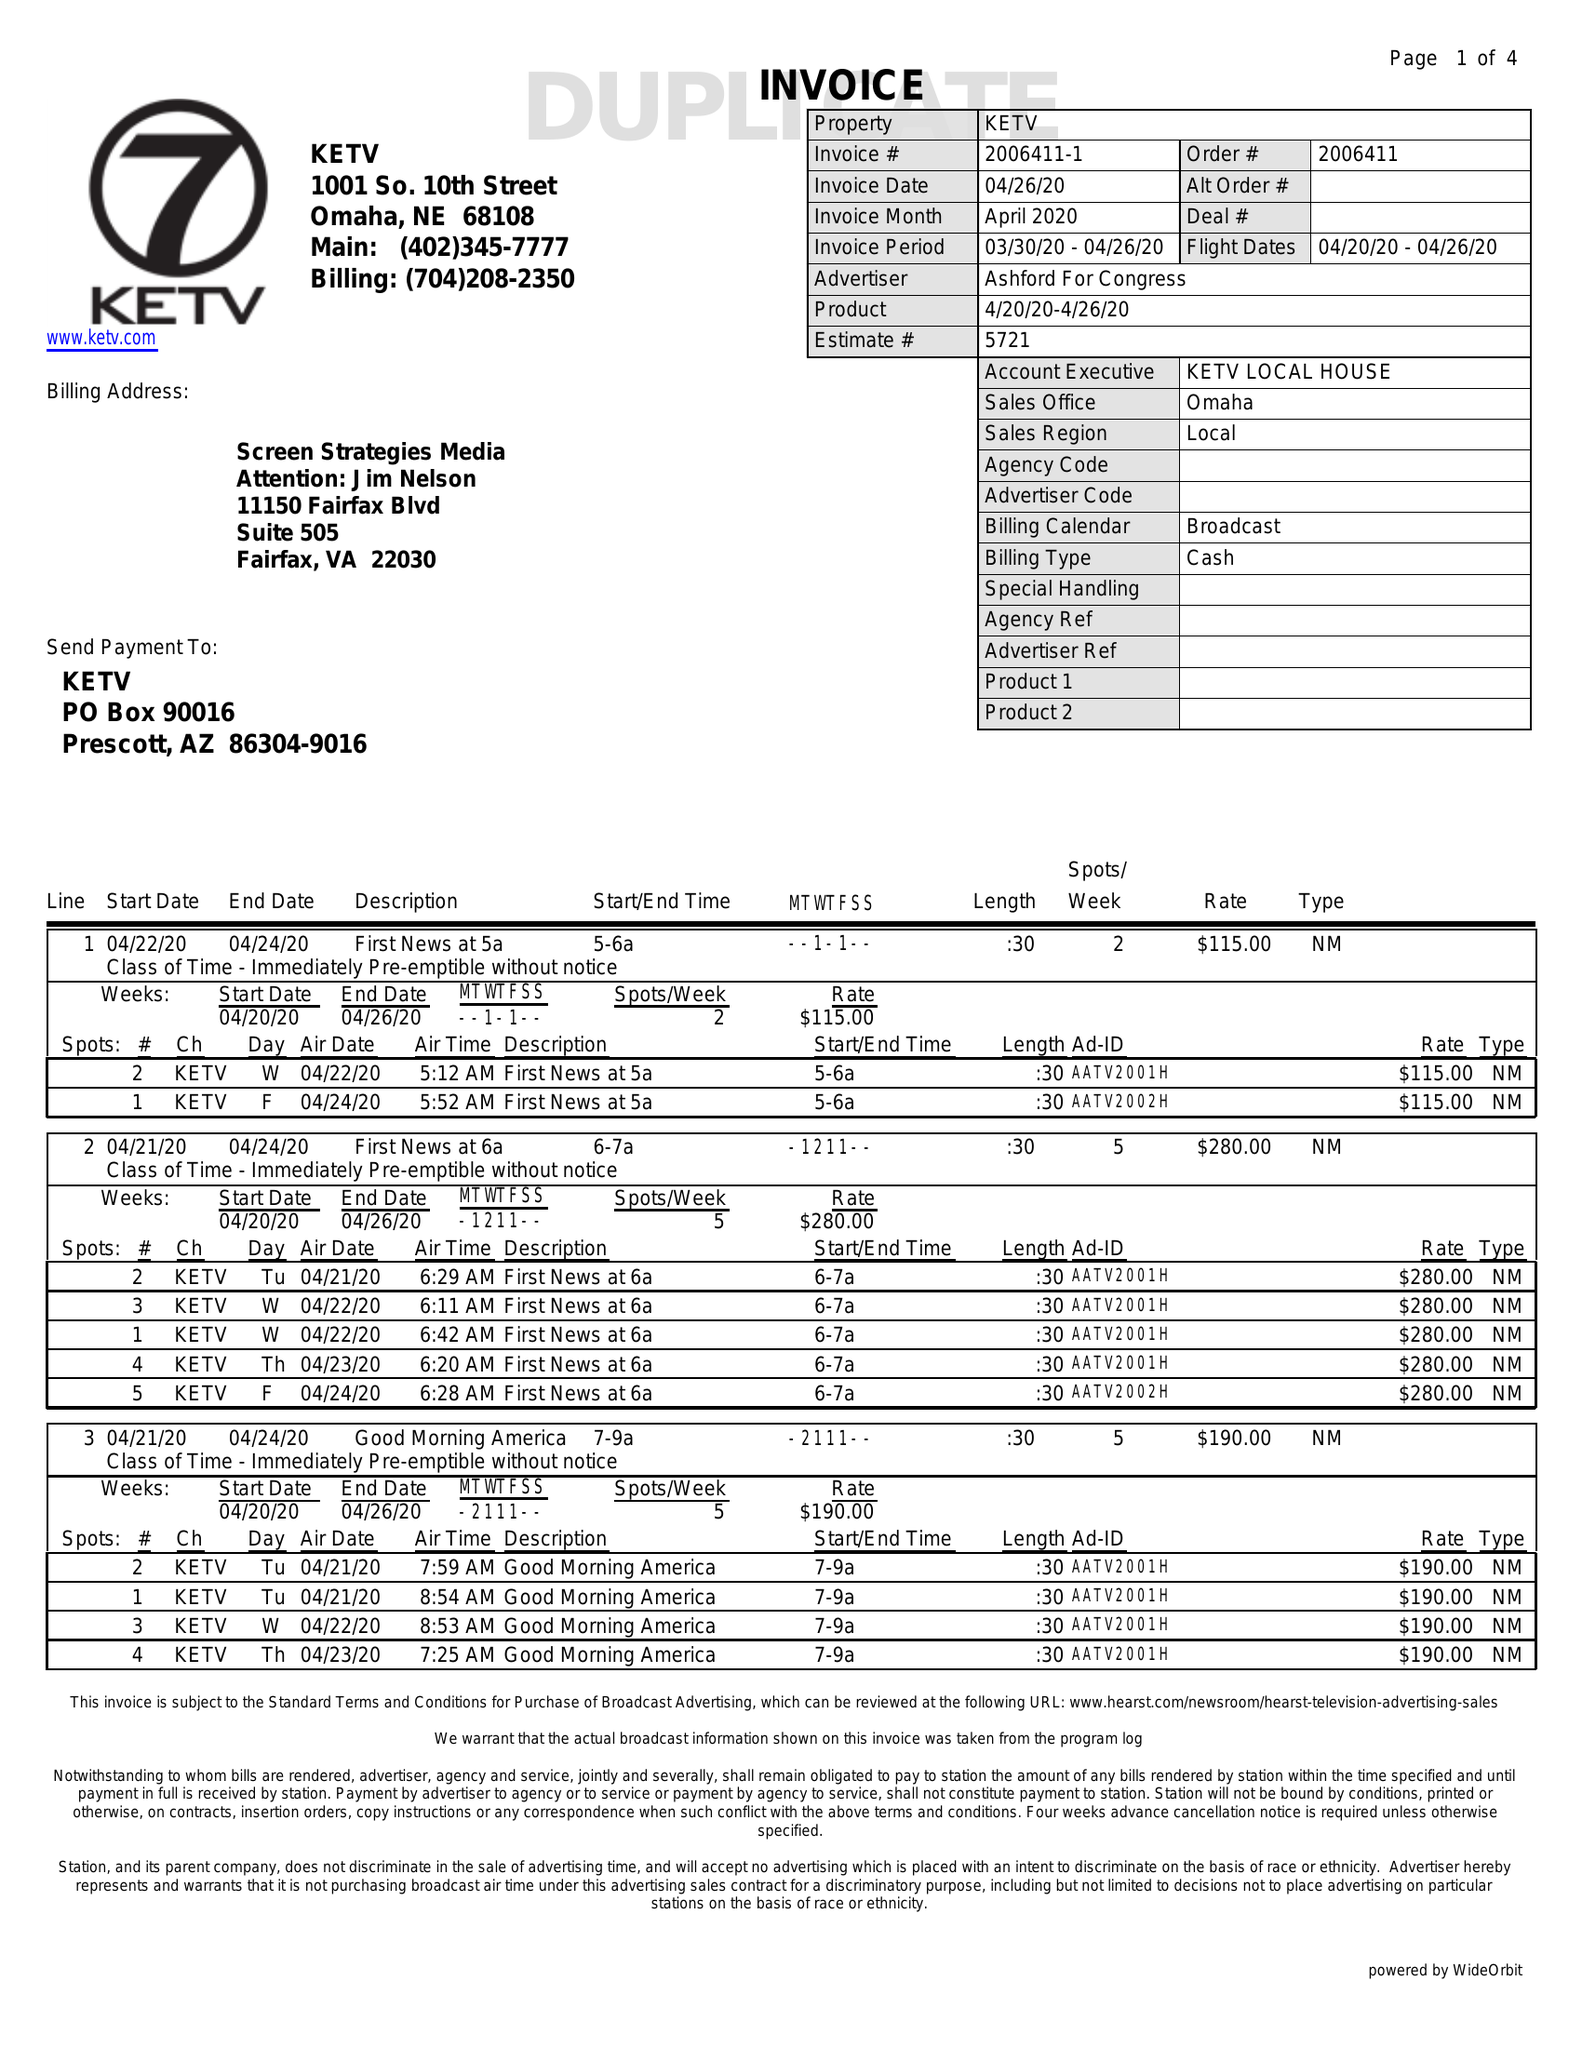What is the value for the advertiser?
Answer the question using a single word or phrase. ASHFORD FOR CONGRESS 